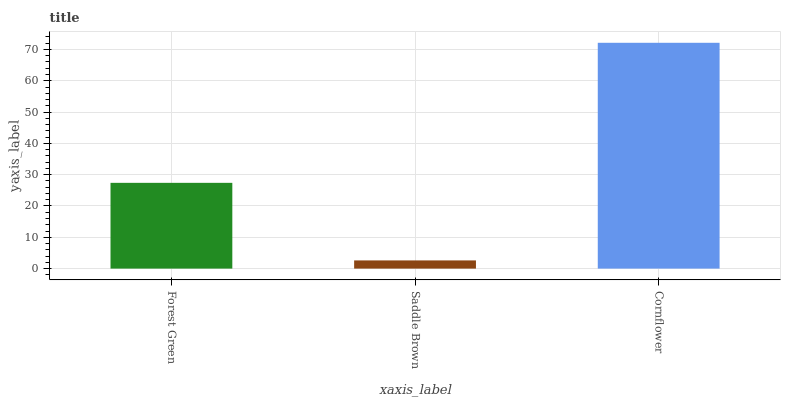Is Saddle Brown the minimum?
Answer yes or no. Yes. Is Cornflower the maximum?
Answer yes or no. Yes. Is Cornflower the minimum?
Answer yes or no. No. Is Saddle Brown the maximum?
Answer yes or no. No. Is Cornflower greater than Saddle Brown?
Answer yes or no. Yes. Is Saddle Brown less than Cornflower?
Answer yes or no. Yes. Is Saddle Brown greater than Cornflower?
Answer yes or no. No. Is Cornflower less than Saddle Brown?
Answer yes or no. No. Is Forest Green the high median?
Answer yes or no. Yes. Is Forest Green the low median?
Answer yes or no. Yes. Is Saddle Brown the high median?
Answer yes or no. No. Is Cornflower the low median?
Answer yes or no. No. 